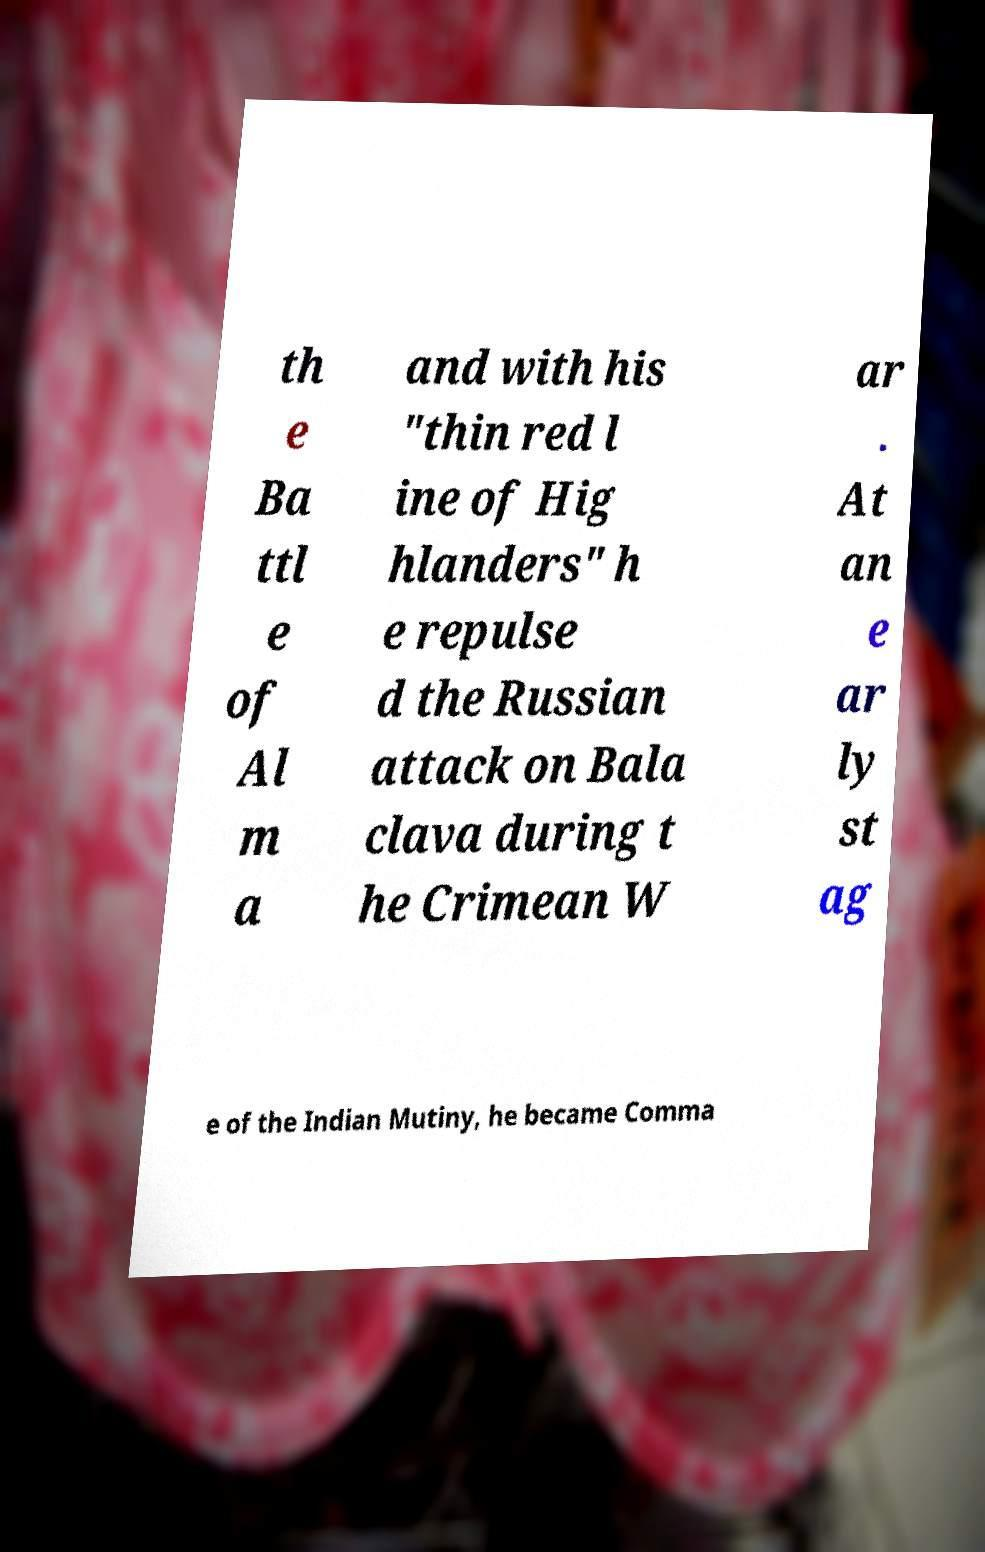There's text embedded in this image that I need extracted. Can you transcribe it verbatim? th e Ba ttl e of Al m a and with his "thin red l ine of Hig hlanders" h e repulse d the Russian attack on Bala clava during t he Crimean W ar . At an e ar ly st ag e of the Indian Mutiny, he became Comma 